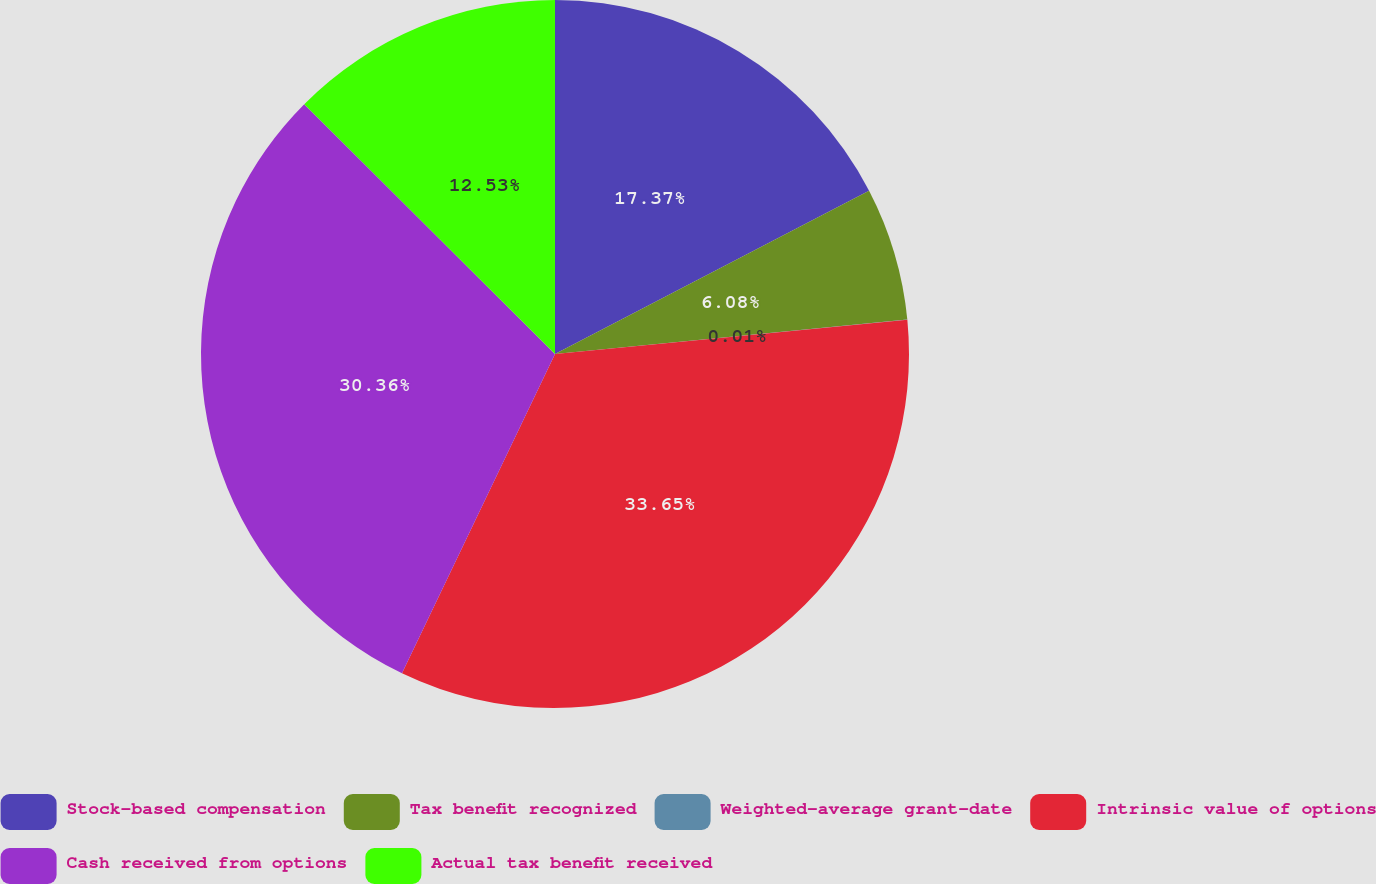Convert chart. <chart><loc_0><loc_0><loc_500><loc_500><pie_chart><fcel>Stock-based compensation<fcel>Tax benefit recognized<fcel>Weighted-average grant-date<fcel>Intrinsic value of options<fcel>Cash received from options<fcel>Actual tax benefit received<nl><fcel>17.37%<fcel>6.08%<fcel>0.01%<fcel>33.66%<fcel>30.36%<fcel>12.53%<nl></chart> 